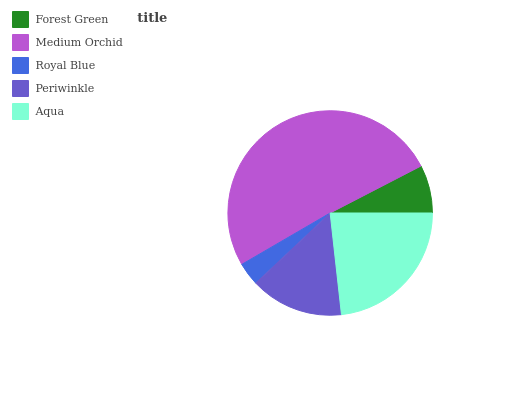Is Royal Blue the minimum?
Answer yes or no. Yes. Is Medium Orchid the maximum?
Answer yes or no. Yes. Is Medium Orchid the minimum?
Answer yes or no. No. Is Royal Blue the maximum?
Answer yes or no. No. Is Medium Orchid greater than Royal Blue?
Answer yes or no. Yes. Is Royal Blue less than Medium Orchid?
Answer yes or no. Yes. Is Royal Blue greater than Medium Orchid?
Answer yes or no. No. Is Medium Orchid less than Royal Blue?
Answer yes or no. No. Is Periwinkle the high median?
Answer yes or no. Yes. Is Periwinkle the low median?
Answer yes or no. Yes. Is Medium Orchid the high median?
Answer yes or no. No. Is Royal Blue the low median?
Answer yes or no. No. 